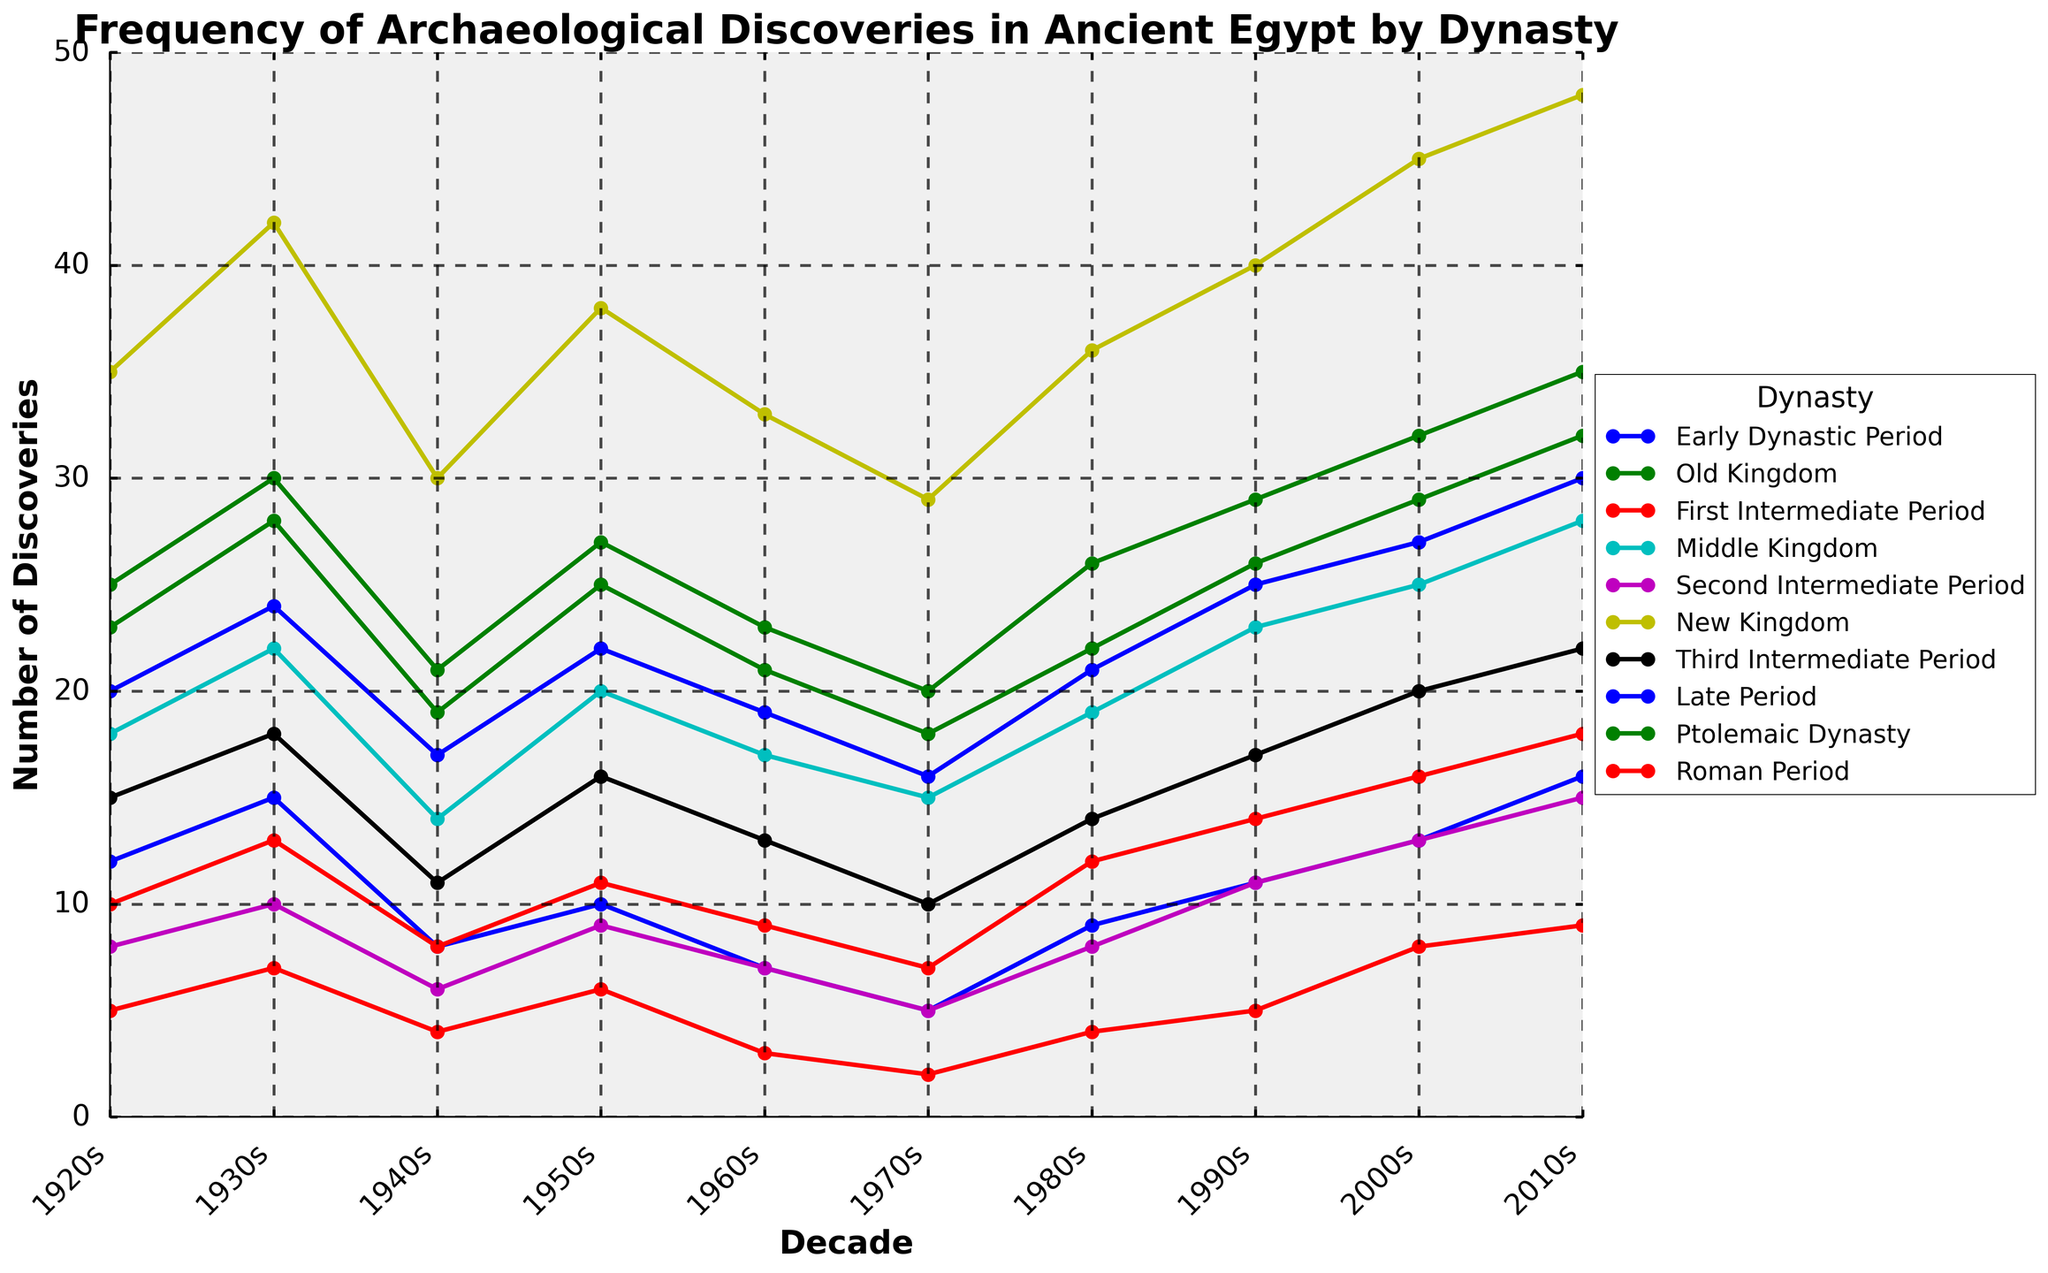What dynasty experienced the highest number of archaeological discoveries in the 2010s? To determine this, look at the end of the lines for the 2010s decade and identify the line that peaks the highest. The New Kingdom line reaches the topmost point.
Answer: New Kingdom Compare the frequency of discoveries in the Old Kingdom between the 1920s and 1930s. What is the difference? Find the values for the Old Kingdom in the 1920s and 1930s, which are 23 and 28 respectively. Subtract the 1920s value from the 1930s value: 28 - 23 = 5.
Answer: 5 During which decade did the Roman Period show an equal number of discoveries as the Early Dynastic Period? Examine the line plots for both the Roman Period and Early Dynastic Period to find a common point. In the 1940s, both have 8 discoveries.
Answer: 1940s Which dynasty shows the lowest frequency of discoveries in the 1970s? Look at the values for each dynasty in the 1970s and identify the lowest number. The First Intermediate Period shows the lowest frequency with 2 discoveries.
Answer: First Intermediate Period Calculate the average number of discoveries for the Middle Kingdom from the 1920s to the 2010s. Add the number of discoveries for the Middle Kingdom in each decade: (18 + 22 + 14 + 20 + 17 + 15 + 19 + 23 + 25 + 28) = 201. Then, divide by the number of decades, which is 10. The average is 201 / 10 = 20.1
Answer: 20.1 Which dynasties had a higher number of discoveries in the 2000s than in the 1990s? Compare the 2000s and 1990s values for each dynasty. Dynasties with higher values in the 2000s are Early Dynastic Period (13 > 11), First Intermediate Period (8 > 5), Middle Kingdom (25 > 23), Second Intermediate Period (13 > 11), and New Kingdom (45 > 40).
Answer: Early Dynastic Period, First Intermediate Period, Middle Kingdom, Second Intermediate Period, New Kingdom During which decade did the Late Period experience exactly 24 discoveries? Trace the line for the Late Period dynasty and find the corresponding decade when it hits 24. This happens in the 1930s.
Answer: 1930s What is the total number of discoveries recorded for the New Kingdom over the entire century? Sum the discoveries for the New Kingdom across all decades: 35 + 42 + 30 + 38 + 33 + 29 + 36 + 40 + 45 + 48 = 376
Answer: 376 How does the trend of discoveries in the Ptolemaic Dynasty from 1920s to 2010s compare with that of the Roman Period? Observe the increasing trend for both dynasties. The Ptolemaic Dynasty starts at 25 and increases to 35, while the Roman Period starts at 10 and increases to 18. Both show upward trends but the slope of the Ptolemaic Dynasty is steeper.
Answer: Ptolemaic Dynasty shows a steeper upward trend Which dynasty showed a decrease in discoveries from the 1920s to the 1960s but then increased again in the succeeding decades? The Third Intermediate Period shows a decrease from 15 in the 1920s to 10 in the 1960s but then increases again in the later decades, hitting 22 in the 2010s.
Answer: Third Intermediate Period 